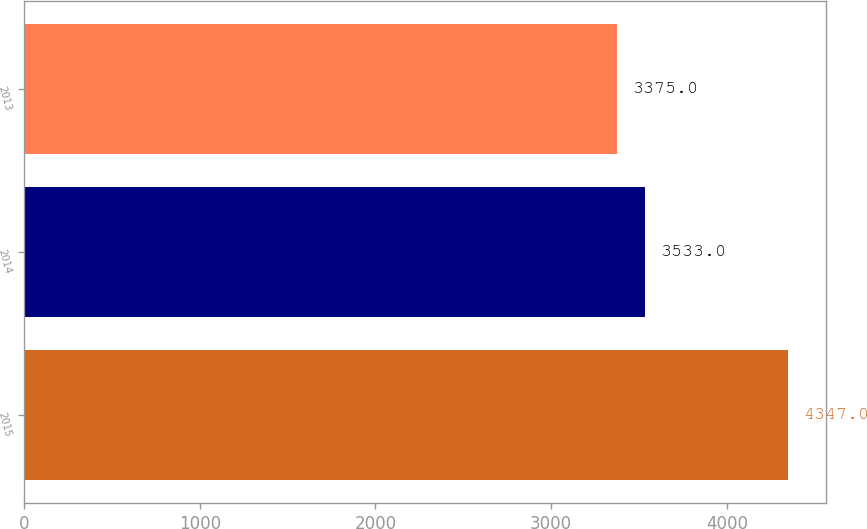Convert chart. <chart><loc_0><loc_0><loc_500><loc_500><bar_chart><fcel>2015<fcel>2014<fcel>2013<nl><fcel>4347<fcel>3533<fcel>3375<nl></chart> 